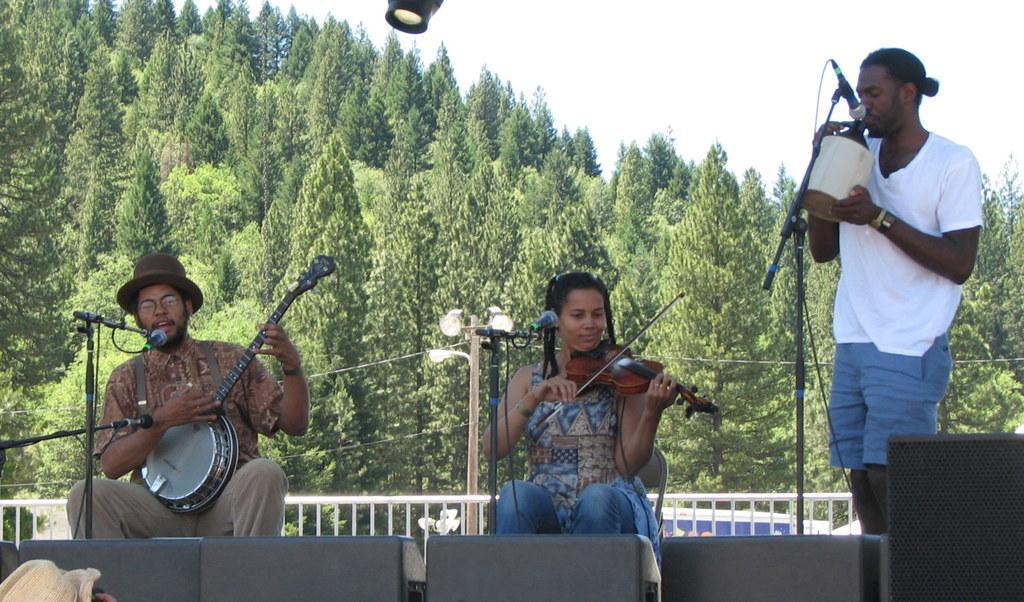Describe this image in one or two sentences. This image is taken in outdoors. There is a sky, there are many trees in this image. In the left side of the image there is a man wearing hat, holding a musical instrument singing in mic. In the middle of the image there is a woman holding violin in her hand sitting on a chair. In the right side of the image there is a man standing in front of mic. In the right side of the image there is a speaker box. In the middle there is a street light. 